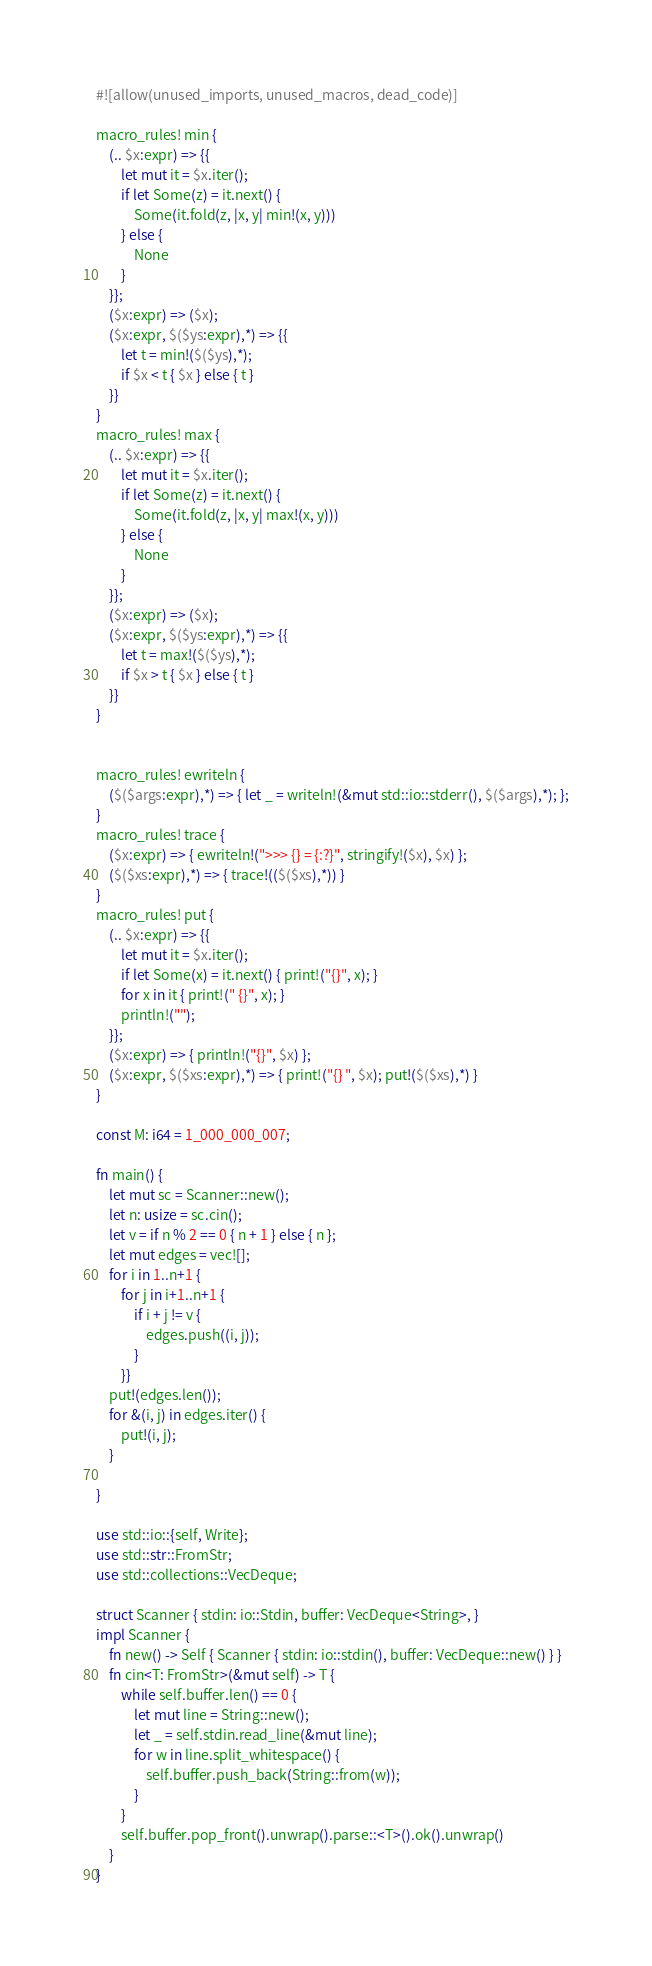Convert code to text. <code><loc_0><loc_0><loc_500><loc_500><_Rust_>#![allow(unused_imports, unused_macros, dead_code)]

macro_rules! min {
    (.. $x:expr) => {{
        let mut it = $x.iter();
        if let Some(z) = it.next() {
            Some(it.fold(z, |x, y| min!(x, y)))
        } else {
            None
        }
    }};
    ($x:expr) => ($x);
    ($x:expr, $($ys:expr),*) => {{
        let t = min!($($ys),*);
        if $x < t { $x } else { t }
    }}
}
macro_rules! max {
    (.. $x:expr) => {{
        let mut it = $x.iter();
        if let Some(z) = it.next() {
            Some(it.fold(z, |x, y| max!(x, y)))
        } else {
            None
        }
    }};
    ($x:expr) => ($x);
    ($x:expr, $($ys:expr),*) => {{
        let t = max!($($ys),*);
        if $x > t { $x } else { t }
    }}
}


macro_rules! ewriteln {
    ($($args:expr),*) => { let _ = writeln!(&mut std::io::stderr(), $($args),*); };
}
macro_rules! trace {
    ($x:expr) => { ewriteln!(">>> {} = {:?}", stringify!($x), $x) };
    ($($xs:expr),*) => { trace!(($($xs),*)) }
}
macro_rules! put {
    (.. $x:expr) => {{
        let mut it = $x.iter();
        if let Some(x) = it.next() { print!("{}", x); }
        for x in it { print!(" {}", x); }
        println!("");
    }};
    ($x:expr) => { println!("{}", $x) };
    ($x:expr, $($xs:expr),*) => { print!("{} ", $x); put!($($xs),*) }
}

const M: i64 = 1_000_000_007;

fn main() {
    let mut sc = Scanner::new();
    let n: usize = sc.cin();
    let v = if n % 2 == 0 { n + 1 } else { n };
    let mut edges = vec![];
    for i in 1..n+1 {
        for j in i+1..n+1 {
            if i + j != v {
                edges.push((i, j));
            }
        }}
    put!(edges.len());
    for &(i, j) in edges.iter() {
        put!(i, j);
    }

}

use std::io::{self, Write};
use std::str::FromStr;
use std::collections::VecDeque;

struct Scanner { stdin: io::Stdin, buffer: VecDeque<String>, }
impl Scanner {
    fn new() -> Self { Scanner { stdin: io::stdin(), buffer: VecDeque::new() } }
    fn cin<T: FromStr>(&mut self) -> T {
        while self.buffer.len() == 0 {
            let mut line = String::new();
            let _ = self.stdin.read_line(&mut line);
            for w in line.split_whitespace() {
                self.buffer.push_back(String::from(w));
            }
        }
        self.buffer.pop_front().unwrap().parse::<T>().ok().unwrap()
    }
}
</code> 